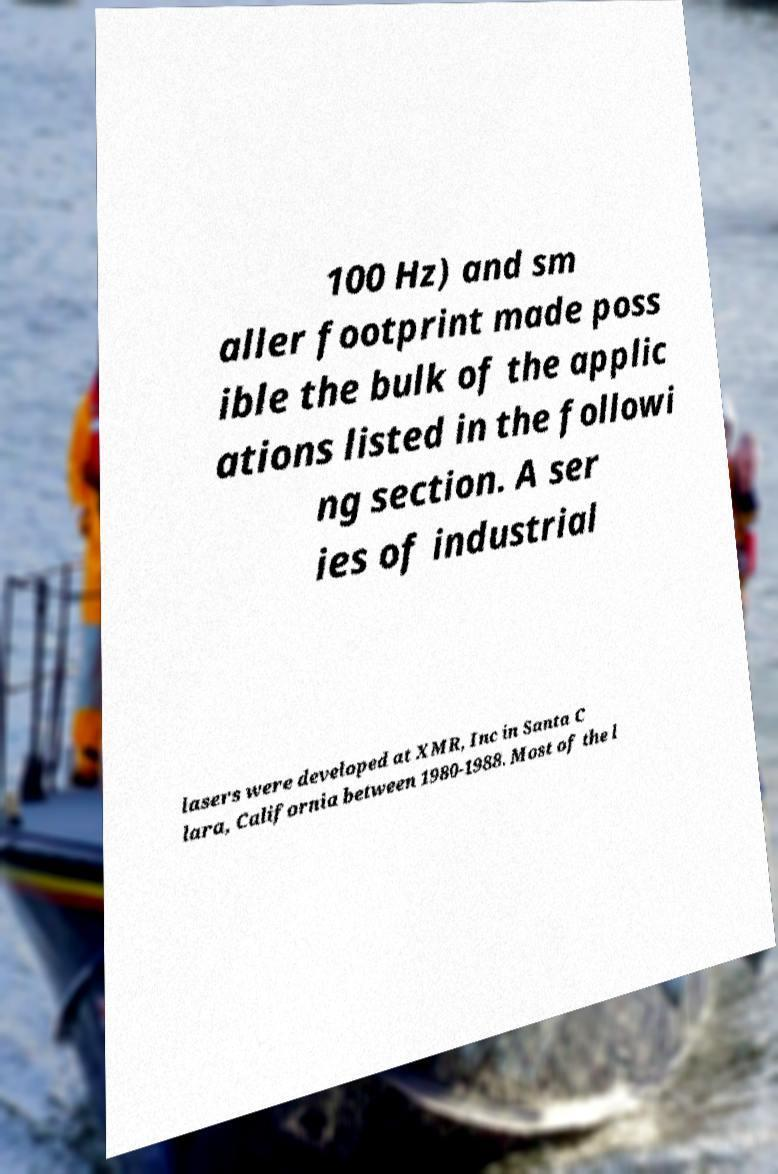Can you accurately transcribe the text from the provided image for me? 100 Hz) and sm aller footprint made poss ible the bulk of the applic ations listed in the followi ng section. A ser ies of industrial lasers were developed at XMR, Inc in Santa C lara, California between 1980-1988. Most of the l 